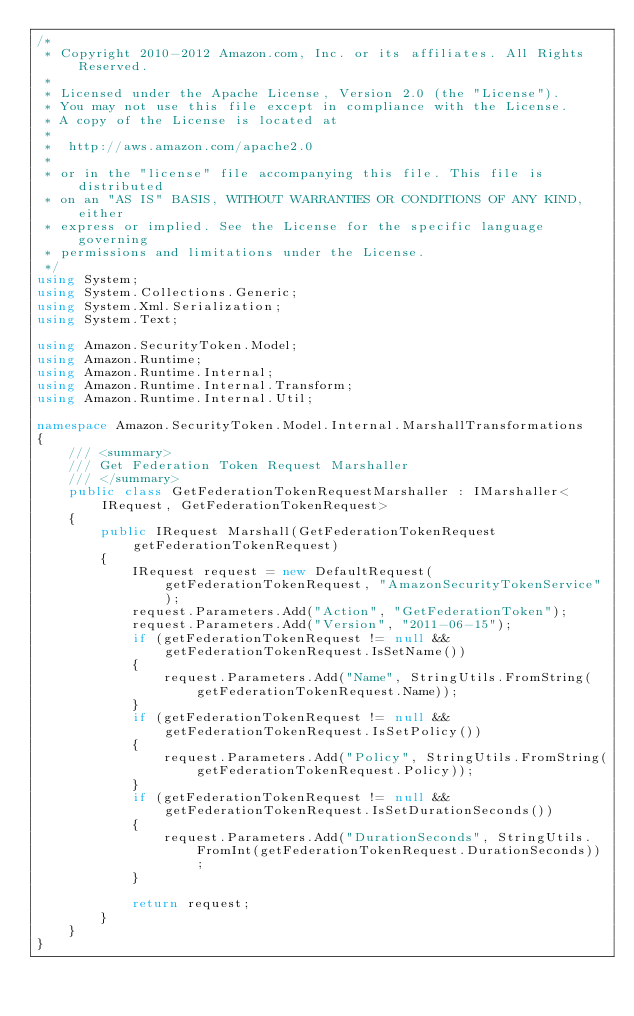<code> <loc_0><loc_0><loc_500><loc_500><_C#_>/*
 * Copyright 2010-2012 Amazon.com, Inc. or its affiliates. All Rights Reserved.
 * 
 * Licensed under the Apache License, Version 2.0 (the "License").
 * You may not use this file except in compliance with the License.
 * A copy of the License is located at
 * 
 *  http://aws.amazon.com/apache2.0
 * 
 * or in the "license" file accompanying this file. This file is distributed
 * on an "AS IS" BASIS, WITHOUT WARRANTIES OR CONDITIONS OF ANY KIND, either
 * express or implied. See the License for the specific language governing
 * permissions and limitations under the License.
 */
using System;
using System.Collections.Generic;
using System.Xml.Serialization;
using System.Text;

using Amazon.SecurityToken.Model;
using Amazon.Runtime;
using Amazon.Runtime.Internal;
using Amazon.Runtime.Internal.Transform;
using Amazon.Runtime.Internal.Util;

namespace Amazon.SecurityToken.Model.Internal.MarshallTransformations
{
    /// <summary>
    /// Get Federation Token Request Marshaller
    /// </summary>       
    public class GetFederationTokenRequestMarshaller : IMarshaller<IRequest, GetFederationTokenRequest>
    {
        public IRequest Marshall(GetFederationTokenRequest getFederationTokenRequest)
        {
            IRequest request = new DefaultRequest(getFederationTokenRequest, "AmazonSecurityTokenService");
            request.Parameters.Add("Action", "GetFederationToken");
            request.Parameters.Add("Version", "2011-06-15");
            if (getFederationTokenRequest != null && getFederationTokenRequest.IsSetName())
            {
                request.Parameters.Add("Name", StringUtils.FromString(getFederationTokenRequest.Name));
            }
            if (getFederationTokenRequest != null && getFederationTokenRequest.IsSetPolicy())
            {
                request.Parameters.Add("Policy", StringUtils.FromString(getFederationTokenRequest.Policy));
            }
            if (getFederationTokenRequest != null && getFederationTokenRequest.IsSetDurationSeconds())
            {
                request.Parameters.Add("DurationSeconds", StringUtils.FromInt(getFederationTokenRequest.DurationSeconds));
            }

            return request;
        }
    }
}
</code> 